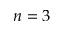<formula> <loc_0><loc_0><loc_500><loc_500>n = 3</formula> 